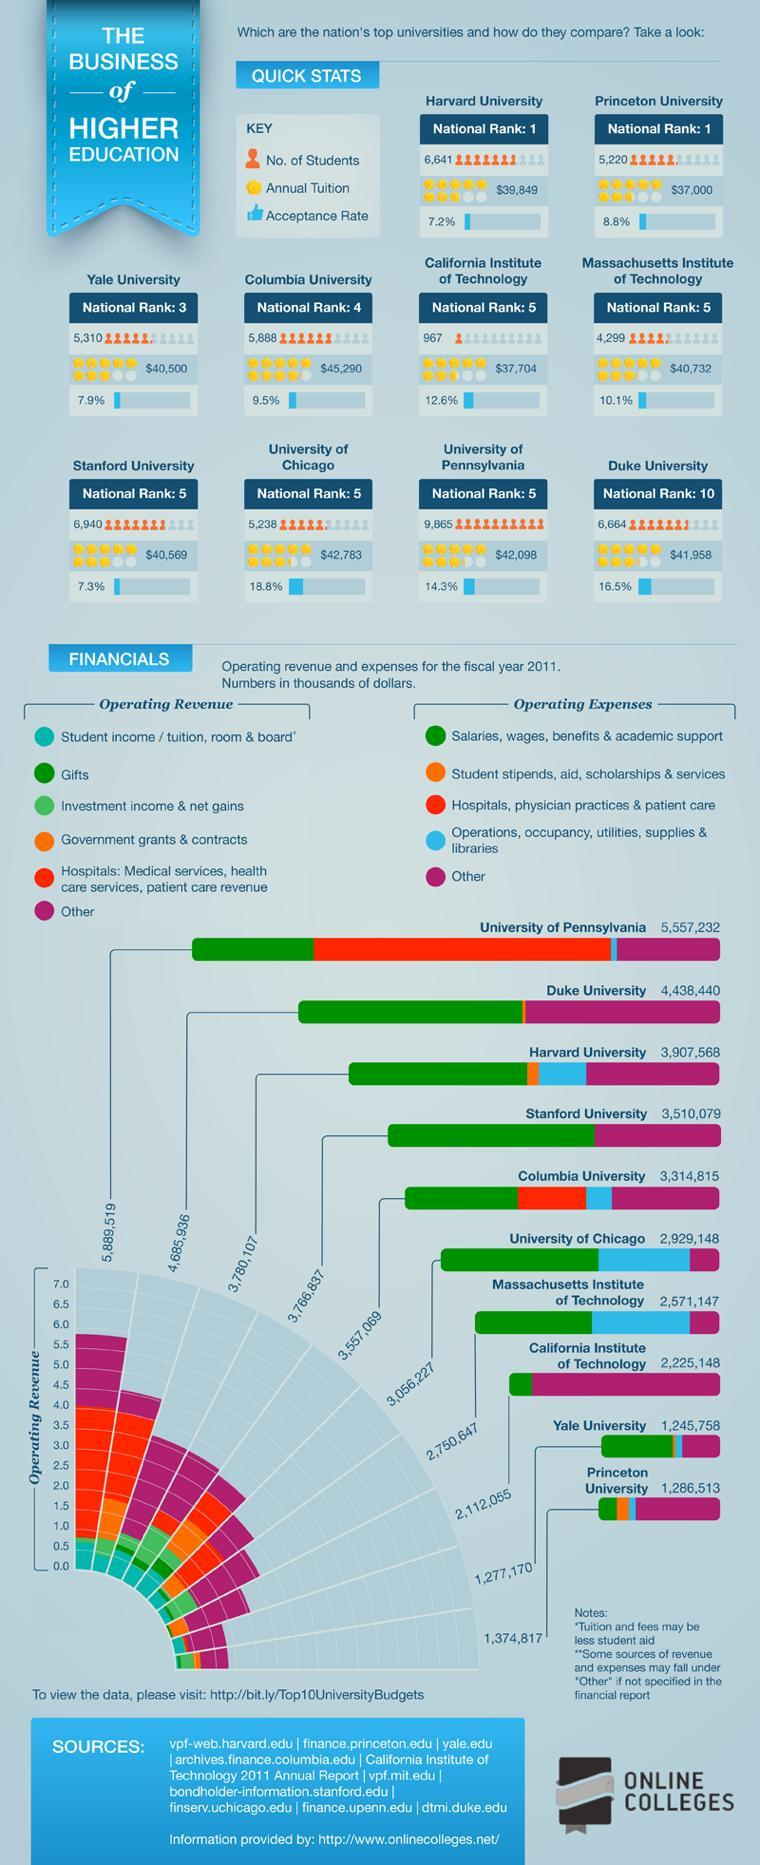How many Universities are listed in the info graphic?
Answer the question with a short phrase. 10 What is the annual Tuition fee in the University Of Chicago? $42,783 How many students are studying in Duke University? 6,664 What is the National Rank of Massachusetts Institute of Technology? 5 What is the National Rank of Duke University? 10 What is the National Rank of Columbia University? 4 What is the acceptance rate in Stanford University? 7.3% How many students are studying in Yale University? 5,310 What is the annual Tuition fee in the Harvard University? $39,849 What is the acceptance rate in Massachusetts Institute of Technology? 10.1% 